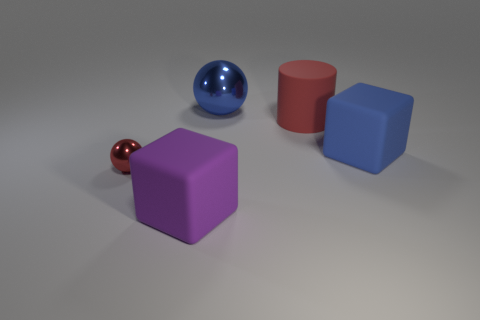Add 2 red balls. How many objects exist? 7 Subtract all spheres. How many objects are left? 3 Add 5 blue objects. How many blue objects are left? 7 Add 5 tiny cyan objects. How many tiny cyan objects exist? 5 Subtract 1 red cylinders. How many objects are left? 4 Subtract all red balls. Subtract all matte cubes. How many objects are left? 2 